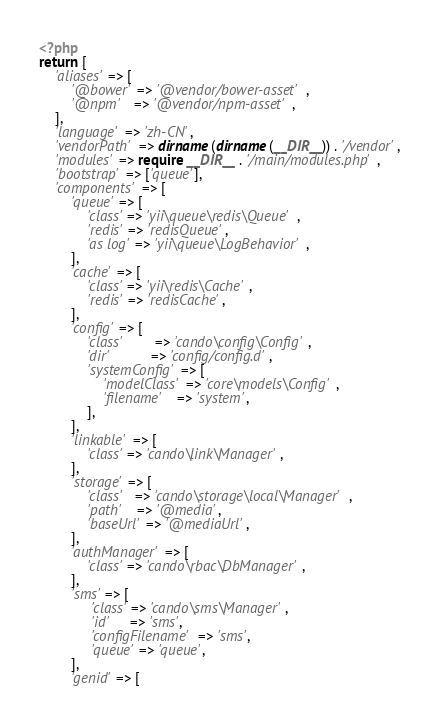<code> <loc_0><loc_0><loc_500><loc_500><_PHP_><?php
return [
    'aliases' => [
        '@bower' => '@vendor/bower-asset',
        '@npm'   => '@vendor/npm-asset',
    ],
    'language' => 'zh-CN',
    'vendorPath' => dirname(dirname(__DIR__)) . '/vendor',
    'modules' => require __DIR__ . '/main/modules.php',
    'bootstrap' => ['queue'],
    'components' => [
        'queue' => [
            'class' => 'yii\queue\redis\Queue',
            'redis' => 'redisQueue',
            'as log' => 'yii\queue\LogBehavior',
        ],
        'cache' => [
            'class' => 'yii\redis\Cache',
            'redis' => 'redisCache',
        ],
        'config' => [ 
            'class'        => 'cando\config\Config',
            'dir'          => 'config/config.d',
            'systemConfig' => [
                'modelClass' => 'core\models\Config',
                'filename'   => 'system',
            ],
        ],
        'linkable' => [
            'class' => 'cando\link\Manager',
        ],
        'storage' => [
            'class'   => 'cando\storage\local\Manager',
            'path'    => '@media',
            'baseUrl' => '@mediaUrl',
        ],
        'authManager' => [
            'class' => 'cando\rbac\DbManager',
        ],
        'sms' => [
             'class' => 'cando\sms\Manager',
             'id'     => 'sms',
             'configFilename' => 'sms',
             'queue' => 'queue',
        ],
        'genid' => [</code> 